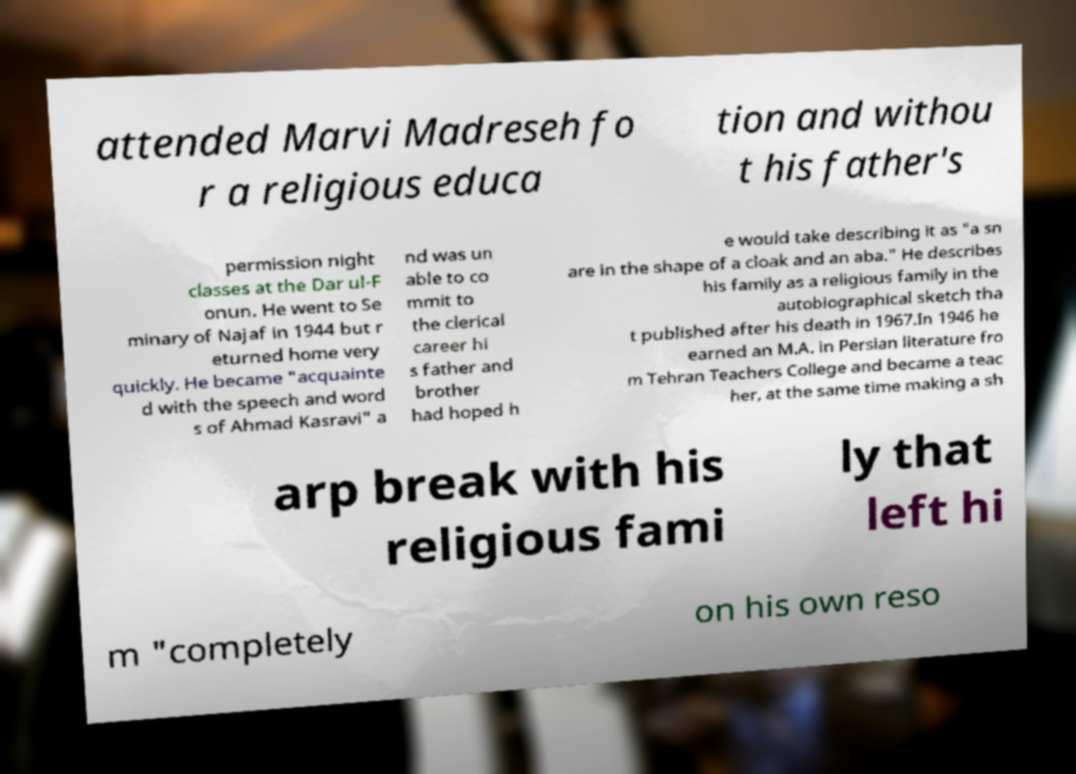For documentation purposes, I need the text within this image transcribed. Could you provide that? attended Marvi Madreseh fo r a religious educa tion and withou t his father's permission night classes at the Dar ul-F onun. He went to Se minary of Najaf in 1944 but r eturned home very quickly. He became "acquainte d with the speech and word s of Ahmad Kasravi" a nd was un able to co mmit to the clerical career hi s father and brother had hoped h e would take describing it as "a sn are in the shape of a cloak and an aba." He describes his family as a religious family in the autobiographical sketch tha t published after his death in 1967.In 1946 he earned an M.A. in Persian literature fro m Tehran Teachers College and became a teac her, at the same time making a sh arp break with his religious fami ly that left hi m "completely on his own reso 